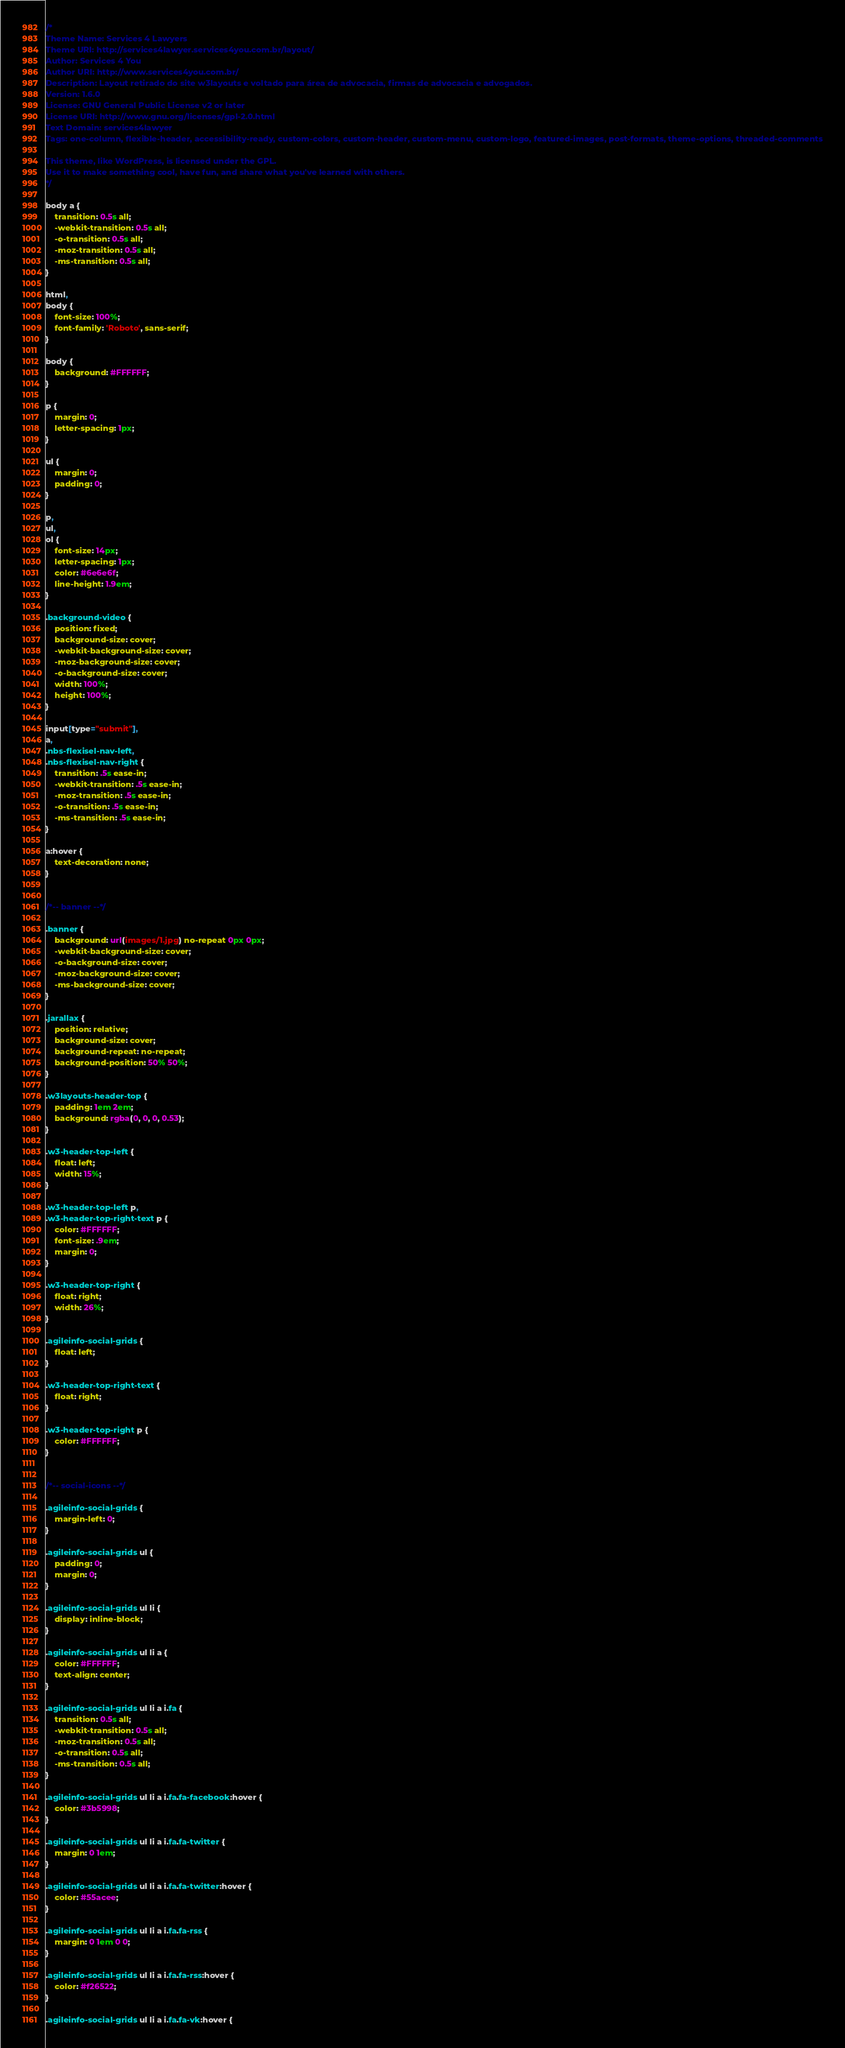<code> <loc_0><loc_0><loc_500><loc_500><_CSS_>/*
Theme Name: Services 4 Lawyers
Theme URI: http://services4lawyer.services4you.com.br/layout/
Author: Services 4 You
Author URI: http://www.services4you.com.br/
Description: Layout retirado do site w3layouts e voltado para área de advocacia, firmas de advocacia e advogados.
Version: 1.6.0
License: GNU General Public License v2 or later
License URI: http://www.gnu.org/licenses/gpl-2.0.html
Text Domain: services4lawyer
Tags: one-column, flexible-header, accessibility-ready, custom-colors, custom-header, custom-menu, custom-logo, featured-images, post-formats, theme-options, threaded-comments

This theme, like WordPress, is licensed under the GPL.
Use it to make something cool, have fun, and share what you've learned with others.
*/

body a {
	transition: 0.5s all;
	-webkit-transition: 0.5s all;
	-o-transition: 0.5s all;
	-moz-transition: 0.5s all;
	-ms-transition: 0.5s all;
}

html,
body {
	font-size: 100%;
	font-family: 'Roboto', sans-serif;
}

body {
	background: #FFFFFF;
}

p {
	margin: 0;
	letter-spacing: 1px;
}

ul {
	margin: 0;
	padding: 0;
}

p,
ul,
ol {
	font-size: 14px;
	letter-spacing: 1px;
	color: #6e6e6f;
	line-height: 1.9em;
}

.background-video {
	position: fixed;
	background-size: cover;
	-webkit-background-size: cover;
	-moz-background-size: cover;
	-o-background-size: cover;
	width: 100%;
	height: 100%;
}

input[type="submit"],
a,
.nbs-flexisel-nav-left,
.nbs-flexisel-nav-right {
	transition: .5s ease-in;
	-webkit-transition: .5s ease-in;
	-moz-transition: .5s ease-in;
	-o-transition: .5s ease-in;
	-ms-transition: .5s ease-in;
}

a:hover {
	text-decoration: none;
}


/*-- banner --*/

.banner {
	background: url(images/1.jpg) no-repeat 0px 0px;
	-webkit-background-size: cover;
	-o-background-size: cover;
	-moz-background-size: cover;
	-ms-background-size: cover;
}

.jarallax {
	position: relative;
	background-size: cover;
	background-repeat: no-repeat;
	background-position: 50% 50%;
}

.w3layouts-header-top {
	padding: 1em 2em;
	background: rgba(0, 0, 0, 0.53);
}

.w3-header-top-left {
	float: left;
	width: 15%;
}

.w3-header-top-left p,
.w3-header-top-right-text p {
	color: #FFFFFF;
	font-size: .9em;
	margin: 0;
}

.w3-header-top-right {
	float: right;
	width: 26%;
}

.agileinfo-social-grids {
	float: left;
}

.w3-header-top-right-text {
	float: right;
}

.w3-header-top-right p {
	color: #FFFFFF;
}


/*-- social-icons --*/

.agileinfo-social-grids {
	margin-left: 0;
}

.agileinfo-social-grids ul {
	padding: 0;
	margin: 0;
}

.agileinfo-social-grids ul li {
	display: inline-block;
}

.agileinfo-social-grids ul li a {
	color: #FFFFFF;
	text-align: center;
}

.agileinfo-social-grids ul li a i.fa {
	transition: 0.5s all;
	-webkit-transition: 0.5s all;
	-moz-transition: 0.5s all;
	-o-transition: 0.5s all;
	-ms-transition: 0.5s all;
}

.agileinfo-social-grids ul li a i.fa.fa-facebook:hover {
	color: #3b5998;
}

.agileinfo-social-grids ul li a i.fa.fa-twitter {
	margin: 0 1em;
}

.agileinfo-social-grids ul li a i.fa.fa-twitter:hover {
	color: #55acee;
}

.agileinfo-social-grids ul li a i.fa.fa-rss {
	margin: 0 1em 0 0;
}

.agileinfo-social-grids ul li a i.fa.fa-rss:hover {
	color: #f26522;
}

.agileinfo-social-grids ul li a i.fa.fa-vk:hover {</code> 